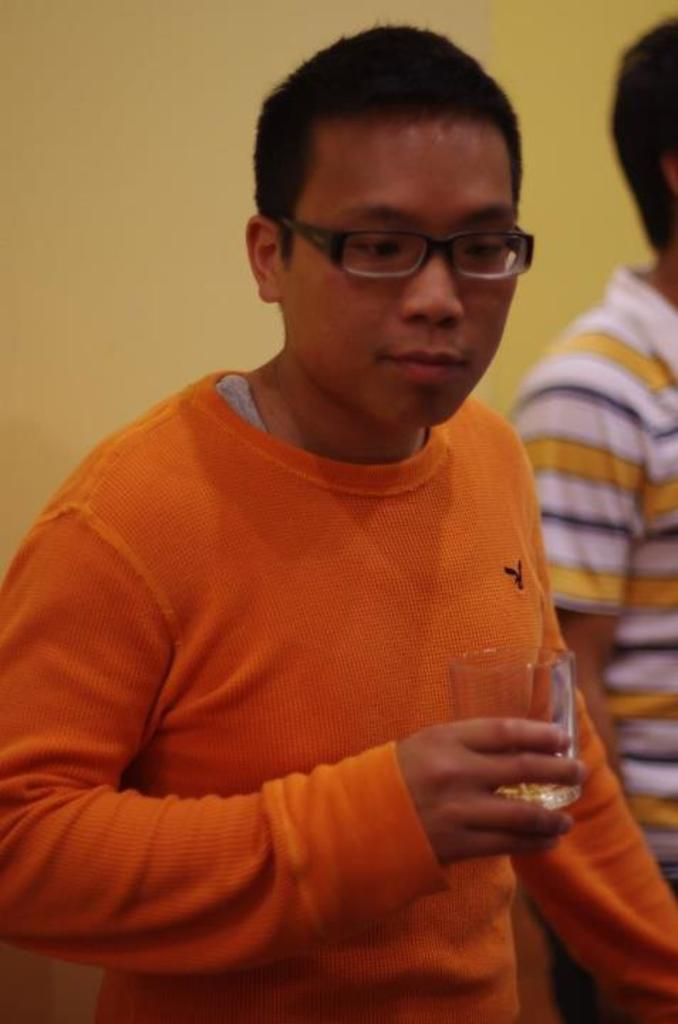Who is the main subject in the image? There is a boy in the image. What is the boy wearing? The boy is wearing an orange t-shirt. What is the boy holding in his hand? The boy is holding a glass in his hand. What is the boy's facial expression or direction of gaze? The boy is looking down. What can be seen in the background of the image? There is a yellow wall in the background of the image. What type of throat medicine is the boy taking in the image? There is no indication in the image that the boy is taking any throat medicine. 